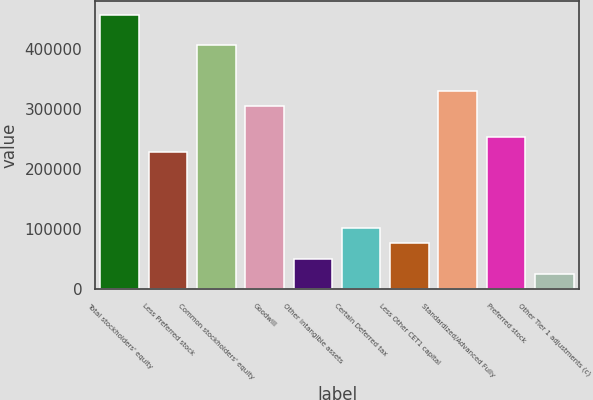Convert chart. <chart><loc_0><loc_0><loc_500><loc_500><bar_chart><fcel>Total stockholders' equity<fcel>Less Preferred stock<fcel>Common stockholders' equity<fcel>Goodwill<fcel>Other intangible assets<fcel>Certain Deferred tax<fcel>Less Other CET1 capital<fcel>Standardized/Advanced Fully<fcel>Preferred stock<fcel>Other Tier 1 adjustments (c)<nl><fcel>457467<fcel>228780<fcel>406648<fcel>305009<fcel>50913.2<fcel>101732<fcel>76322.8<fcel>330419<fcel>254190<fcel>25503.6<nl></chart> 